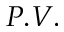Convert formula to latex. <formula><loc_0><loc_0><loc_500><loc_500>P . V .</formula> 